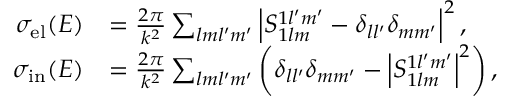Convert formula to latex. <formula><loc_0><loc_0><loc_500><loc_500>\begin{array} { r l } { \sigma _ { e l } ( E ) } & { = \frac { 2 \pi } { k ^ { 2 } } \sum _ { l m l ^ { \prime } m ^ { \prime } } \left | S _ { 1 l m } ^ { 1 l ^ { \prime } m ^ { \prime } } - \delta _ { l l ^ { \prime } } \delta _ { m m ^ { \prime } } \right | ^ { 2 } , } \\ { \sigma _ { i n } ( E ) } & { = \frac { 2 \pi } { k ^ { 2 } } \sum _ { l m l ^ { \prime } m ^ { \prime } } \left ( \delta _ { l l ^ { \prime } } \delta _ { m m ^ { \prime } } - \left | S _ { 1 l m } ^ { 1 l ^ { \prime } m ^ { \prime } } \right | ^ { 2 } \right ) , } \end{array}</formula> 